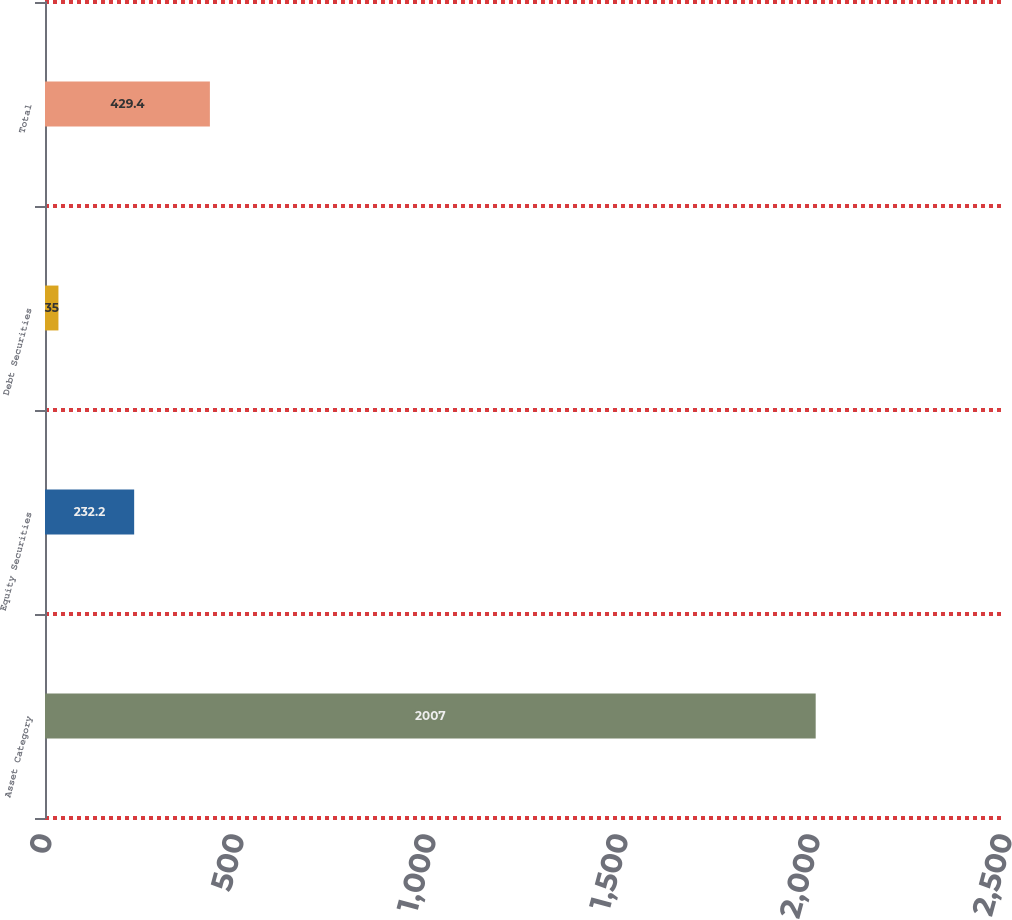Convert chart. <chart><loc_0><loc_0><loc_500><loc_500><bar_chart><fcel>Asset Category<fcel>Equity Securities<fcel>Debt Securities<fcel>Total<nl><fcel>2007<fcel>232.2<fcel>35<fcel>429.4<nl></chart> 